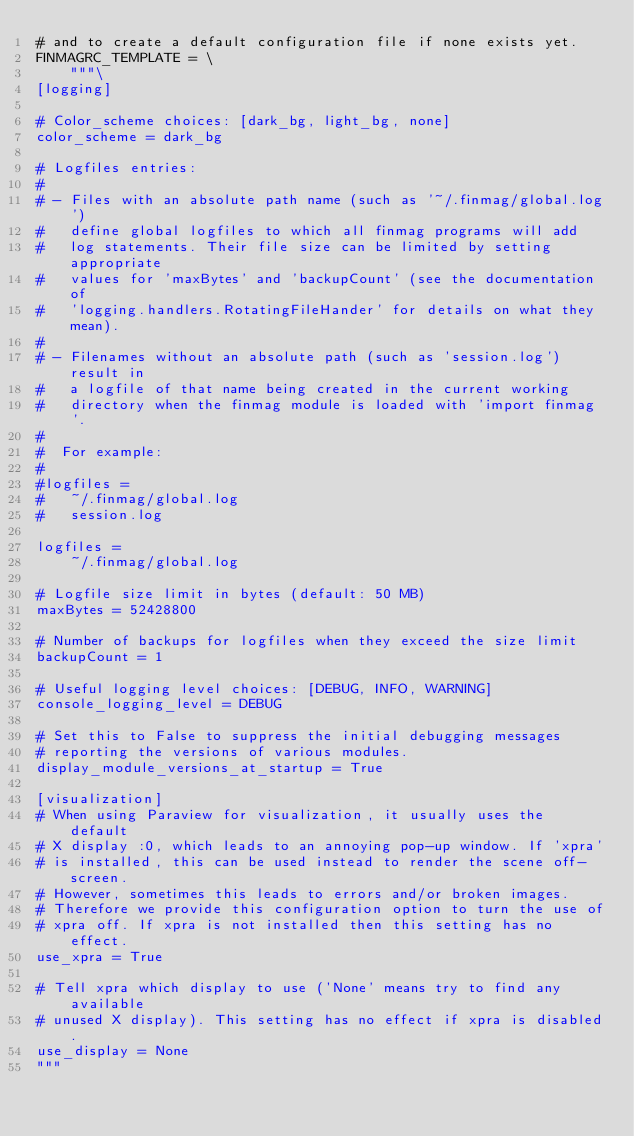<code> <loc_0><loc_0><loc_500><loc_500><_Python_># and to create a default configuration file if none exists yet.
FINMAGRC_TEMPLATE = \
    """\
[logging]

# Color_scheme choices: [dark_bg, light_bg, none]
color_scheme = dark_bg

# Logfiles entries:
#
# - Files with an absolute path name (such as '~/.finmag/global.log')
#   define global logfiles to which all finmag programs will add
#   log statements. Their file size can be limited by setting appropriate
#   values for 'maxBytes' and 'backupCount' (see the documentation of
#   'logging.handlers.RotatingFileHander' for details on what they mean).
#
# - Filenames without an absolute path (such as 'session.log') result in
#   a logfile of that name being created in the current working
#   directory when the finmag module is loaded with 'import finmag'.
#
#  For example:
#
#logfiles =
#   ~/.finmag/global.log
#   session.log

logfiles =
    ~/.finmag/global.log

# Logfile size limit in bytes (default: 50 MB)
maxBytes = 52428800

# Number of backups for logfiles when they exceed the size limit
backupCount = 1

# Useful logging level choices: [DEBUG, INFO, WARNING]
console_logging_level = DEBUG

# Set this to False to suppress the initial debugging messages
# reporting the versions of various modules.
display_module_versions_at_startup = True

[visualization]
# When using Paraview for visualization, it usually uses the default
# X display :0, which leads to an annoying pop-up window. If 'xpra'
# is installed, this can be used instead to render the scene off-screen.
# However, sometimes this leads to errors and/or broken images.
# Therefore we provide this configuration option to turn the use of
# xpra off. If xpra is not installed then this setting has no effect.
use_xpra = True

# Tell xpra which display to use ('None' means try to find any available
# unused X display). This setting has no effect if xpra is disabled.
use_display = None
"""
</code> 